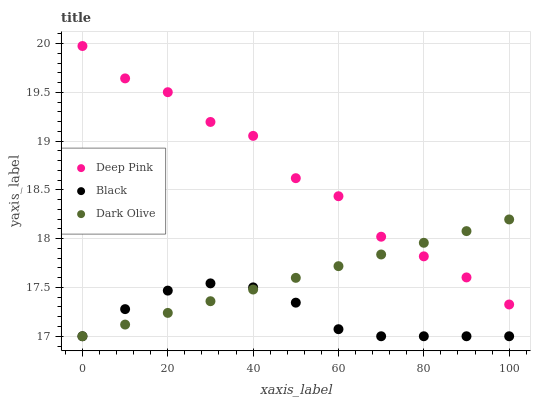Does Black have the minimum area under the curve?
Answer yes or no. Yes. Does Deep Pink have the maximum area under the curve?
Answer yes or no. Yes. Does Deep Pink have the minimum area under the curve?
Answer yes or no. No. Does Black have the maximum area under the curve?
Answer yes or no. No. Is Dark Olive the smoothest?
Answer yes or no. Yes. Is Deep Pink the roughest?
Answer yes or no. Yes. Is Black the smoothest?
Answer yes or no. No. Is Black the roughest?
Answer yes or no. No. Does Dark Olive have the lowest value?
Answer yes or no. Yes. Does Deep Pink have the lowest value?
Answer yes or no. No. Does Deep Pink have the highest value?
Answer yes or no. Yes. Does Black have the highest value?
Answer yes or no. No. Is Black less than Deep Pink?
Answer yes or no. Yes. Is Deep Pink greater than Black?
Answer yes or no. Yes. Does Dark Olive intersect Deep Pink?
Answer yes or no. Yes. Is Dark Olive less than Deep Pink?
Answer yes or no. No. Is Dark Olive greater than Deep Pink?
Answer yes or no. No. Does Black intersect Deep Pink?
Answer yes or no. No. 